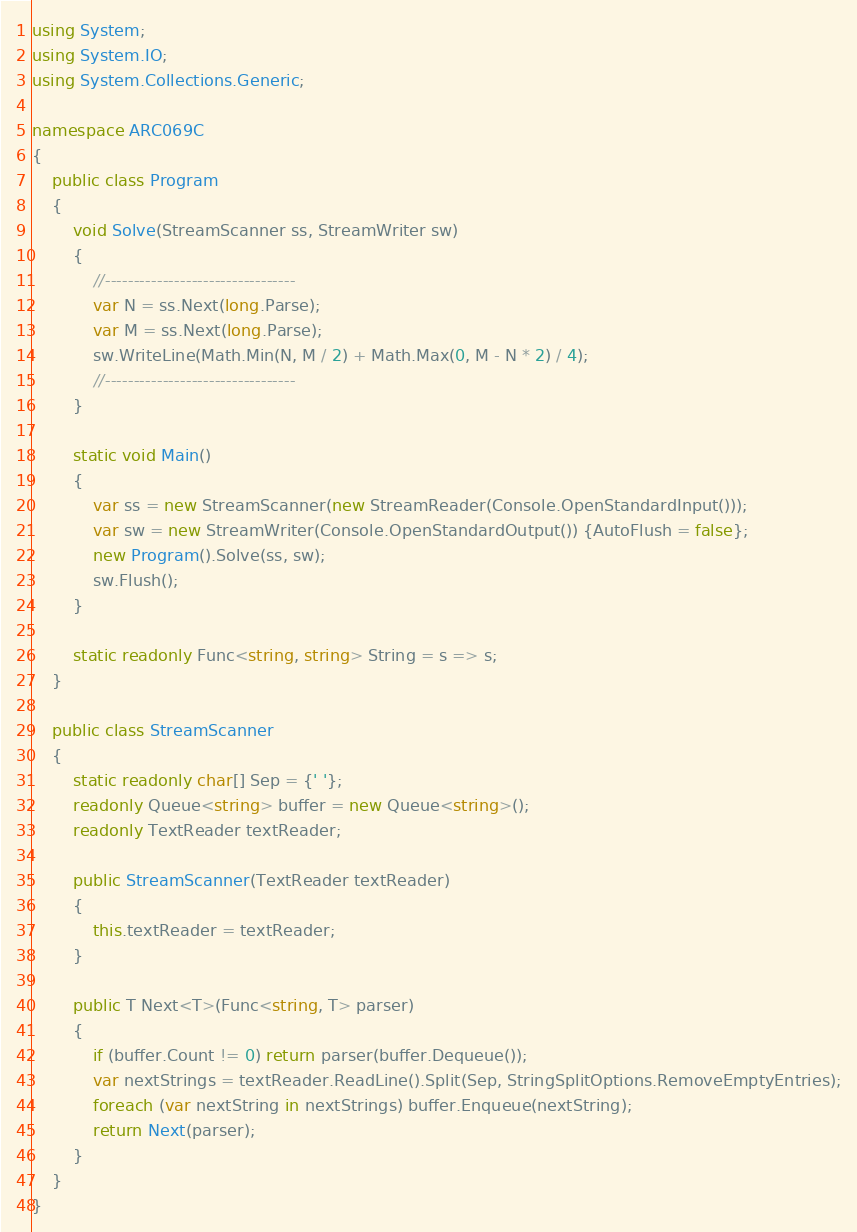<code> <loc_0><loc_0><loc_500><loc_500><_C#_>using System;
using System.IO;
using System.Collections.Generic;

namespace ARC069C
{
    public class Program
    {
        void Solve(StreamScanner ss, StreamWriter sw)
        {
            //---------------------------------
            var N = ss.Next(long.Parse);
            var M = ss.Next(long.Parse);
            sw.WriteLine(Math.Min(N, M / 2) + Math.Max(0, M - N * 2) / 4);
            //---------------------------------
        }

        static void Main()
        {
            var ss = new StreamScanner(new StreamReader(Console.OpenStandardInput()));
            var sw = new StreamWriter(Console.OpenStandardOutput()) {AutoFlush = false};
            new Program().Solve(ss, sw);
            sw.Flush();
        }

        static readonly Func<string, string> String = s => s;
    }

    public class StreamScanner
    {
        static readonly char[] Sep = {' '};
        readonly Queue<string> buffer = new Queue<string>();
        readonly TextReader textReader;

        public StreamScanner(TextReader textReader)
        {
            this.textReader = textReader;
        }

        public T Next<T>(Func<string, T> parser)
        {
            if (buffer.Count != 0) return parser(buffer.Dequeue());
            var nextStrings = textReader.ReadLine().Split(Sep, StringSplitOptions.RemoveEmptyEntries);
            foreach (var nextString in nextStrings) buffer.Enqueue(nextString);
            return Next(parser);
        }
    }
}</code> 